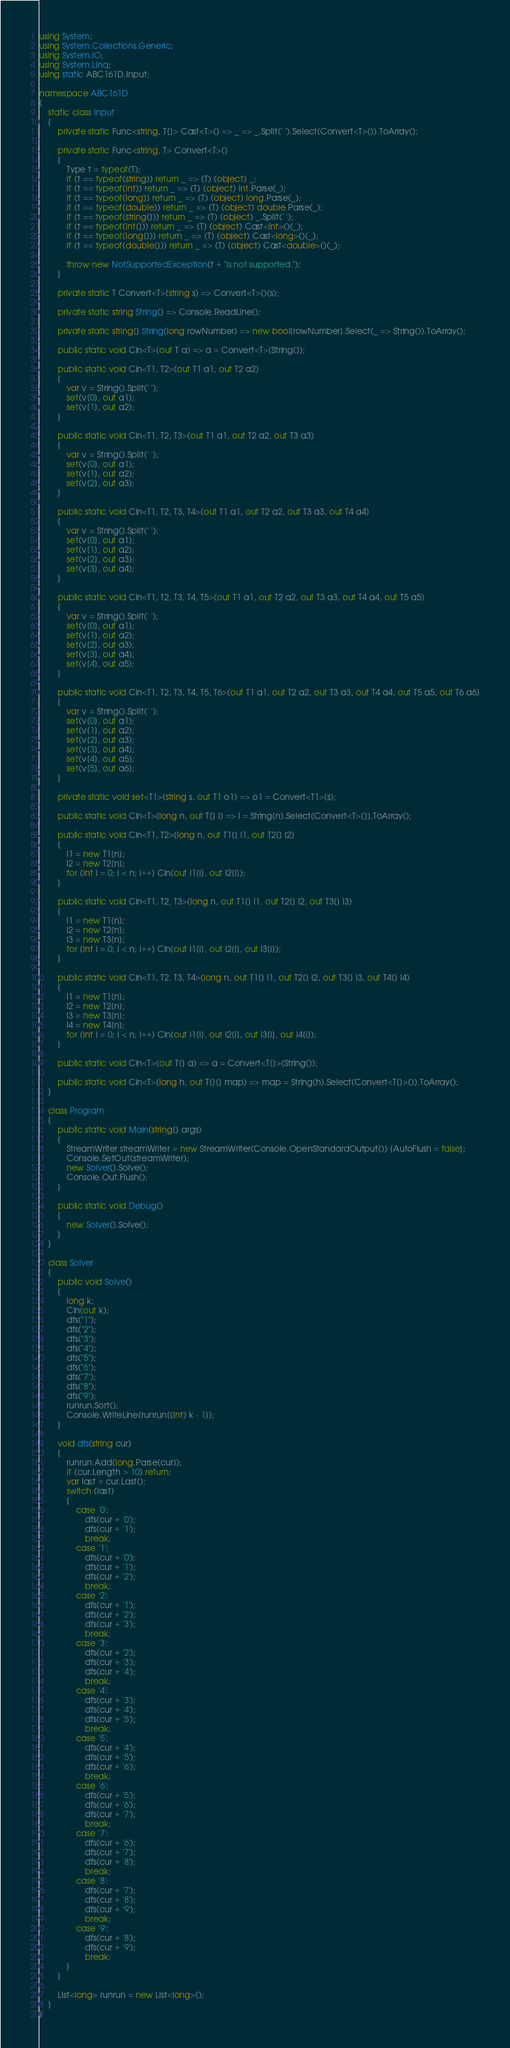<code> <loc_0><loc_0><loc_500><loc_500><_C#_>using System;
using System.Collections.Generic;
using System.IO;
using System.Linq;
using static ABC161D.Input;

namespace ABC161D
{
    static class Input
    {
        private static Func<string, T[]> Cast<T>() => _ => _.Split(' ').Select(Convert<T>()).ToArray();

        private static Func<string, T> Convert<T>()
        {
            Type t = typeof(T);
            if (t == typeof(string)) return _ => (T) (object) _;
            if (t == typeof(int)) return _ => (T) (object) int.Parse(_);
            if (t == typeof(long)) return _ => (T) (object) long.Parse(_);
            if (t == typeof(double)) return _ => (T) (object) double.Parse(_);
            if (t == typeof(string[])) return _ => (T) (object) _.Split(' ');
            if (t == typeof(int[])) return _ => (T) (object) Cast<int>()(_);
            if (t == typeof(long[])) return _ => (T) (object) Cast<long>()(_);
            if (t == typeof(double[])) return _ => (T) (object) Cast<double>()(_);

            throw new NotSupportedException(t + "is not supported.");
        }

        private static T Convert<T>(string s) => Convert<T>()(s);

        private static string String() => Console.ReadLine();

        private static string[] String(long rowNumber) => new bool[rowNumber].Select(_ => String()).ToArray();

        public static void Cin<T>(out T a) => a = Convert<T>(String());

        public static void Cin<T1, T2>(out T1 a1, out T2 a2)
        {
            var v = String().Split(' ');
            set(v[0], out a1);
            set(v[1], out a2);
        }

        public static void Cin<T1, T2, T3>(out T1 a1, out T2 a2, out T3 a3)
        {
            var v = String().Split(' ');
            set(v[0], out a1);
            set(v[1], out a2);
            set(v[2], out a3);
        }

        public static void Cin<T1, T2, T3, T4>(out T1 a1, out T2 a2, out T3 a3, out T4 a4)
        {
            var v = String().Split(' ');
            set(v[0], out a1);
            set(v[1], out a2);
            set(v[2], out a3);
            set(v[3], out a4);
        }

        public static void Cin<T1, T2, T3, T4, T5>(out T1 a1, out T2 a2, out T3 a3, out T4 a4, out T5 a5)
        {
            var v = String().Split(' ');
            set(v[0], out a1);
            set(v[1], out a2);
            set(v[2], out a3);
            set(v[3], out a4);
            set(v[4], out a5);
        }

        public static void Cin<T1, T2, T3, T4, T5, T6>(out T1 a1, out T2 a2, out T3 a3, out T4 a4, out T5 a5, out T6 a6)
        {
            var v = String().Split(' ');
            set(v[0], out a1);
            set(v[1], out a2);
            set(v[2], out a3);
            set(v[3], out a4);
            set(v[4], out a5);
            set(v[5], out a6);
        }

        private static void set<T1>(string s, out T1 o1) => o1 = Convert<T1>(s);

        public static void Cin<T>(long n, out T[] l) => l = String(n).Select(Convert<T>()).ToArray();

        public static void Cin<T1, T2>(long n, out T1[] l1, out T2[] l2)
        {
            l1 = new T1[n];
            l2 = new T2[n];
            for (int i = 0; i < n; i++) Cin(out l1[i], out l2[i]);
        }

        public static void Cin<T1, T2, T3>(long n, out T1[] l1, out T2[] l2, out T3[] l3)
        {
            l1 = new T1[n];
            l2 = new T2[n];
            l3 = new T3[n];
            for (int i = 0; i < n; i++) Cin(out l1[i], out l2[i], out l3[i]);
        }

        public static void Cin<T1, T2, T3, T4>(long n, out T1[] l1, out T2[] l2, out T3[] l3, out T4[] l4)
        {
            l1 = new T1[n];
            l2 = new T2[n];
            l3 = new T3[n];
            l4 = new T4[n];
            for (int i = 0; i < n; i++) Cin(out l1[i], out l2[i], out l3[i], out l4[i]);
        }

        public static void Cin<T>(out T[] a) => a = Convert<T[]>(String());

        public static void Cin<T>(long h, out T[][] map) => map = String(h).Select(Convert<T[]>()).ToArray();
    }

    class Program
    {
        public static void Main(string[] args)
        {
            StreamWriter streamWriter = new StreamWriter(Console.OpenStandardOutput()) {AutoFlush = false};
            Console.SetOut(streamWriter);
            new Solver().Solve();
            Console.Out.Flush();
        }

        public static void Debug()
        {
            new Solver().Solve();
        }
    }

    class Solver
    {
        public void Solve()
        {
            long k;
            Cin(out k);
            dfs("1");
            dfs("2");
            dfs("3");
            dfs("4");
            dfs("5");
            dfs("6");
            dfs("7");
            dfs("8");
            dfs("9");
            runrun.Sort();
            Console.WriteLine(runrun[(int) k - 1]);
        }

        void dfs(string cur)
        {
            runrun.Add(long.Parse(cur));
            if (cur.Length > 10) return;
            var last = cur.Last();
            switch (last)
            {
                case '0':
                    dfs(cur + '0');
                    dfs(cur + '1');
                    break;
                case '1':
                    dfs(cur + '0');
                    dfs(cur + '1');
                    dfs(cur + '2');
                    break;
                case '2':
                    dfs(cur + '1');
                    dfs(cur + '2');
                    dfs(cur + '3');
                    break;
                case '3':
                    dfs(cur + '2');
                    dfs(cur + '3');
                    dfs(cur + '4');
                    break;
                case '4':
                    dfs(cur + '3');
                    dfs(cur + '4');
                    dfs(cur + '5');
                    break;
                case '5':
                    dfs(cur + '4');
                    dfs(cur + '5');
                    dfs(cur + '6');
                    break;
                case '6':
                    dfs(cur + '5');
                    dfs(cur + '6');
                    dfs(cur + '7');
                    break;
                case '7':
                    dfs(cur + '6');
                    dfs(cur + '7');
                    dfs(cur + '8');
                    break;
                case '8':
                    dfs(cur + '7');
                    dfs(cur + '8');
                    dfs(cur + '9');
                    break;
                case '9':
                    dfs(cur + '8');
                    dfs(cur + '9');
                    break;
            }
        }

        List<long> runrun = new List<long>();
    }
}</code> 